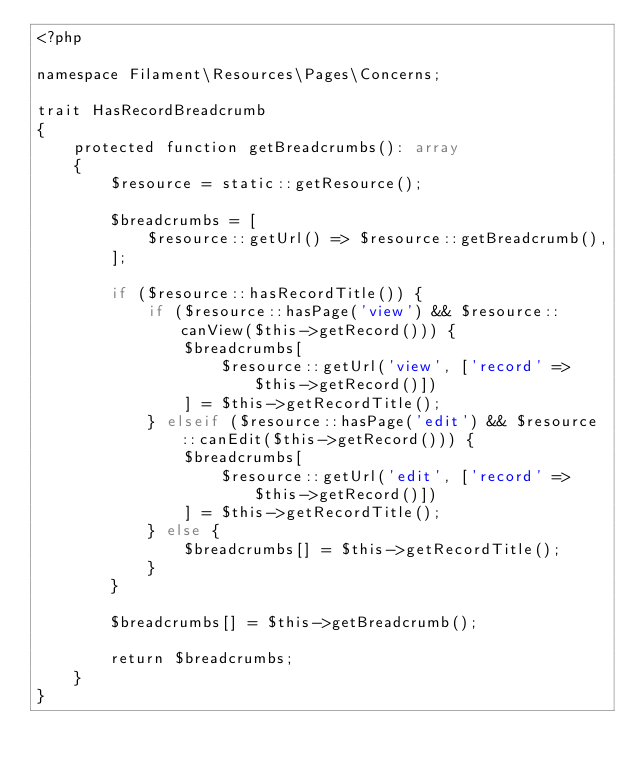Convert code to text. <code><loc_0><loc_0><loc_500><loc_500><_PHP_><?php

namespace Filament\Resources\Pages\Concerns;

trait HasRecordBreadcrumb
{
    protected function getBreadcrumbs(): array
    {
        $resource = static::getResource();

        $breadcrumbs = [
            $resource::getUrl() => $resource::getBreadcrumb(),
        ];

        if ($resource::hasRecordTitle()) {
            if ($resource::hasPage('view') && $resource::canView($this->getRecord())) {
                $breadcrumbs[
                    $resource::getUrl('view', ['record' => $this->getRecord()])
                ] = $this->getRecordTitle();
            } elseif ($resource::hasPage('edit') && $resource::canEdit($this->getRecord())) {
                $breadcrumbs[
                    $resource::getUrl('edit', ['record' => $this->getRecord()])
                ] = $this->getRecordTitle();
            } else {
                $breadcrumbs[] = $this->getRecordTitle();
            }
        }

        $breadcrumbs[] = $this->getBreadcrumb();

        return $breadcrumbs;
    }
}
</code> 